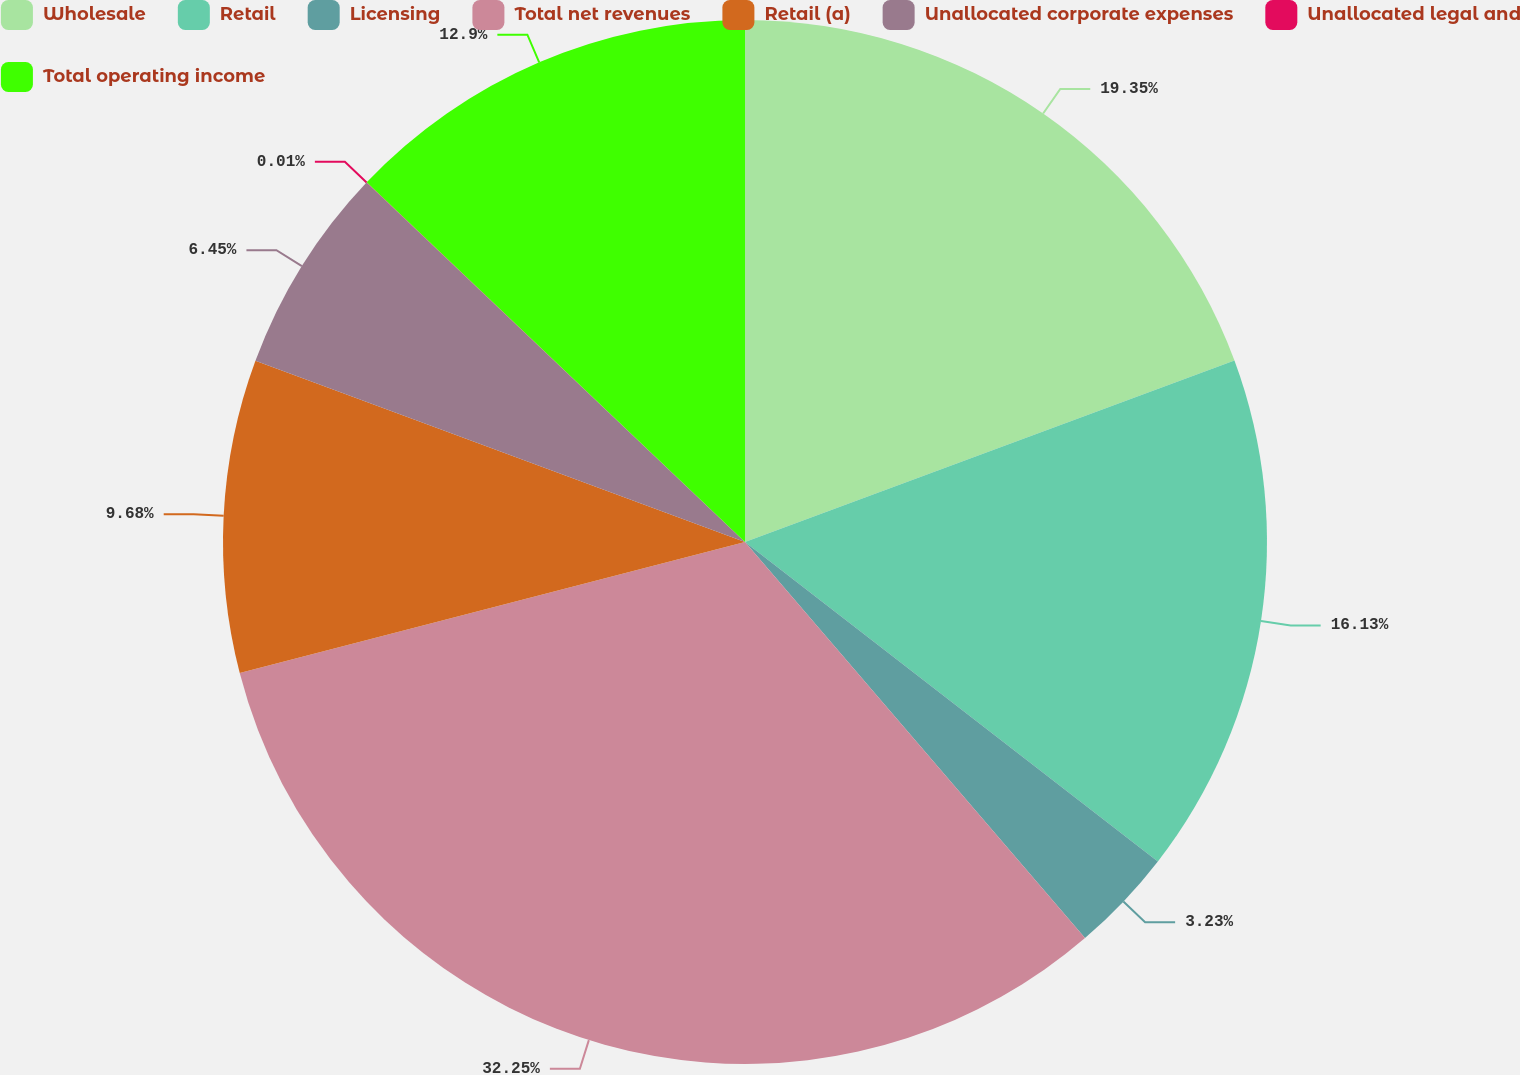Convert chart. <chart><loc_0><loc_0><loc_500><loc_500><pie_chart><fcel>Wholesale<fcel>Retail<fcel>Licensing<fcel>Total net revenues<fcel>Retail (a)<fcel>Unallocated corporate expenses<fcel>Unallocated legal and<fcel>Total operating income<nl><fcel>19.35%<fcel>16.13%<fcel>3.23%<fcel>32.25%<fcel>9.68%<fcel>6.45%<fcel>0.01%<fcel>12.9%<nl></chart> 